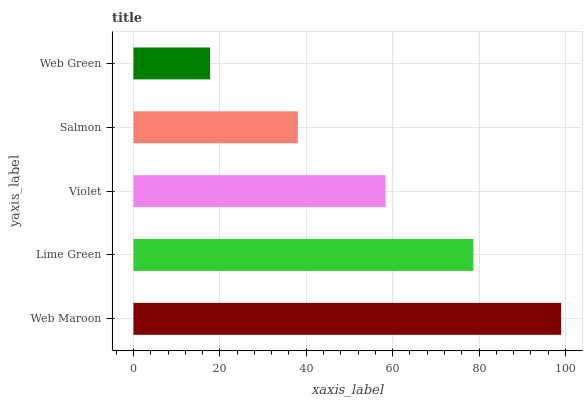Is Web Green the minimum?
Answer yes or no. Yes. Is Web Maroon the maximum?
Answer yes or no. Yes. Is Lime Green the minimum?
Answer yes or no. No. Is Lime Green the maximum?
Answer yes or no. No. Is Web Maroon greater than Lime Green?
Answer yes or no. Yes. Is Lime Green less than Web Maroon?
Answer yes or no. Yes. Is Lime Green greater than Web Maroon?
Answer yes or no. No. Is Web Maroon less than Lime Green?
Answer yes or no. No. Is Violet the high median?
Answer yes or no. Yes. Is Violet the low median?
Answer yes or no. Yes. Is Lime Green the high median?
Answer yes or no. No. Is Web Green the low median?
Answer yes or no. No. 